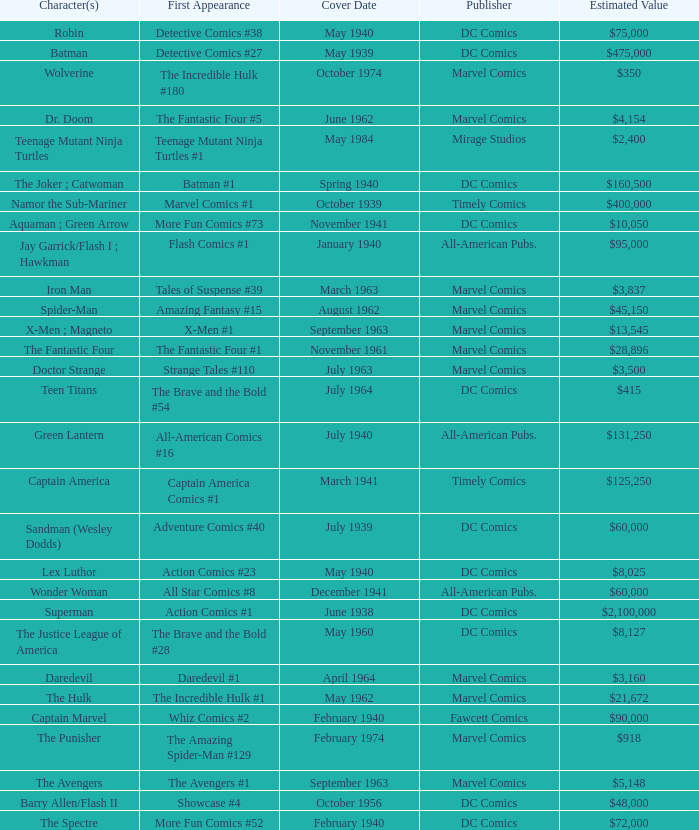What is Action Comics #1's estimated value? $2,100,000. 